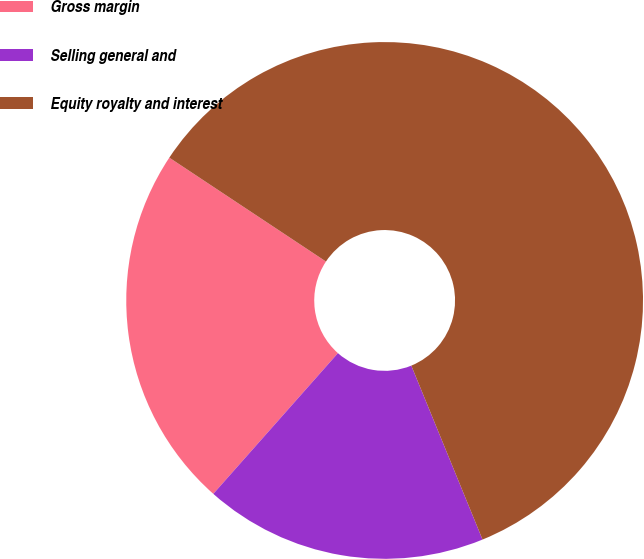Convert chart to OTSL. <chart><loc_0><loc_0><loc_500><loc_500><pie_chart><fcel>Gross margin<fcel>Selling general and<fcel>Equity royalty and interest<nl><fcel>22.78%<fcel>17.72%<fcel>59.49%<nl></chart> 